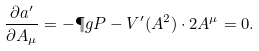<formula> <loc_0><loc_0><loc_500><loc_500>\frac { \partial \L a ^ { \prime } } { \partial A _ { \mu } } = - \P g P - V ^ { \prime } ( A ^ { 2 } ) \cdot 2 A ^ { \mu } = 0 .</formula> 